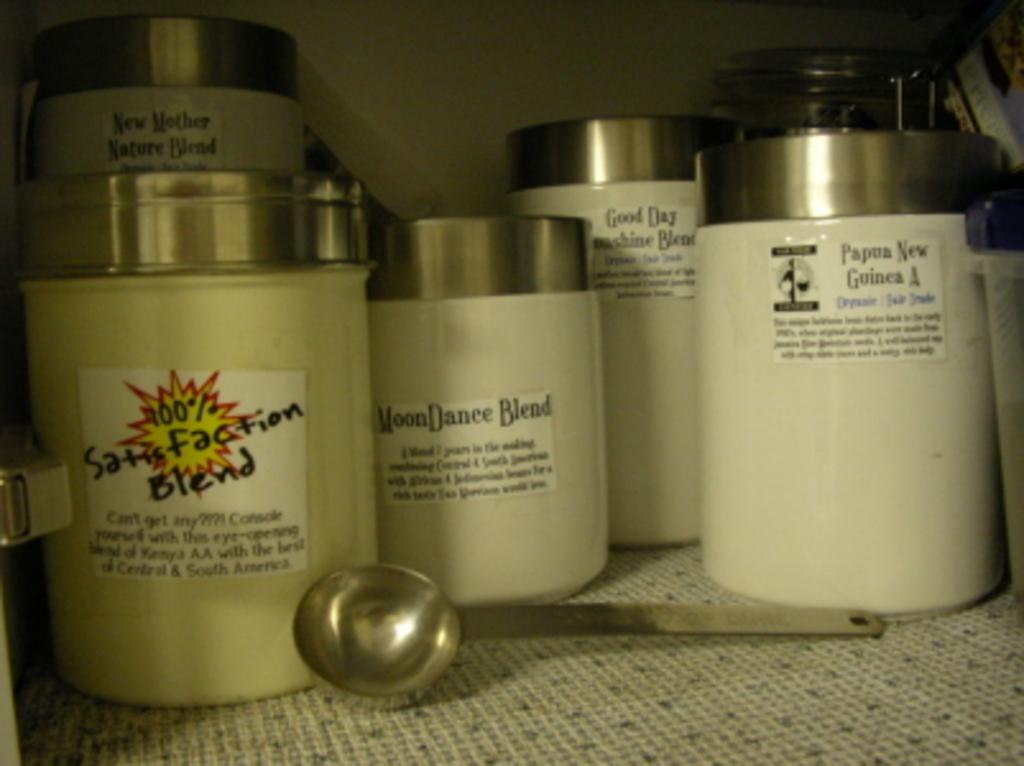<image>
Offer a succinct explanation of the picture presented. Jars of different blends on a counter, including one called 100% Satisfaction Blend. 